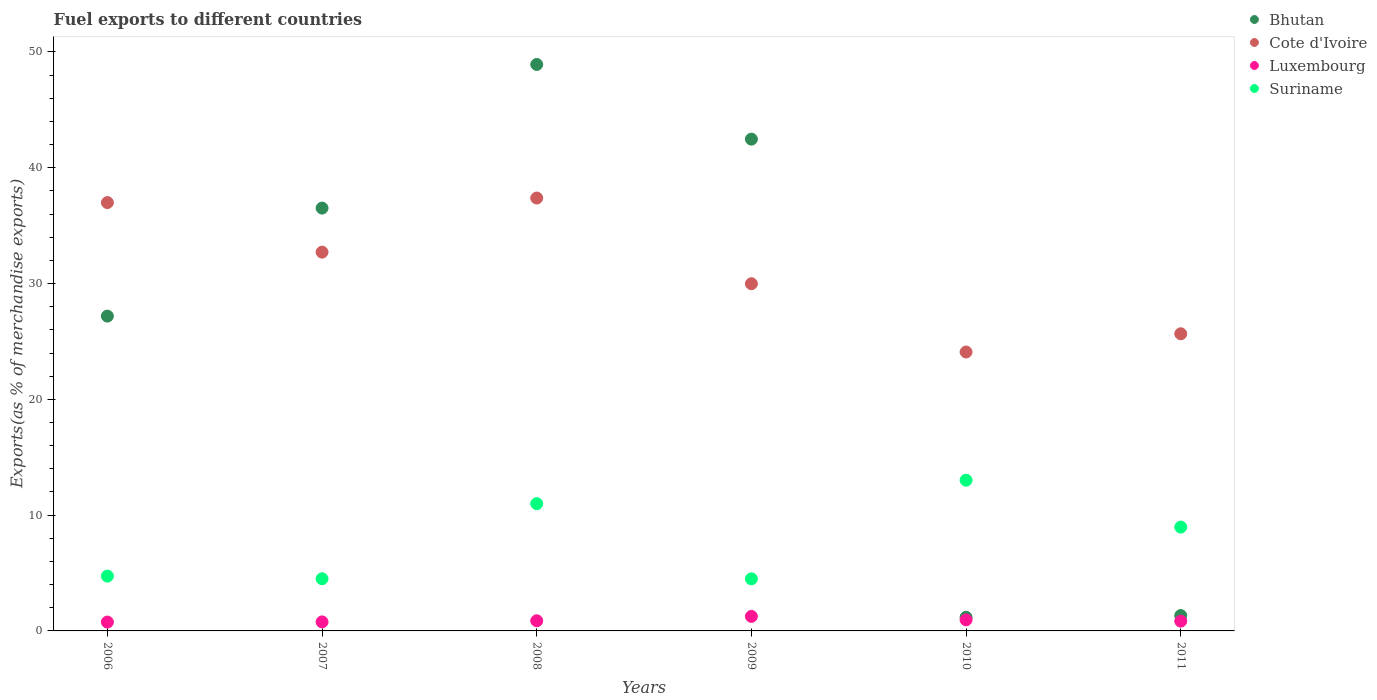What is the percentage of exports to different countries in Suriname in 2006?
Your response must be concise. 4.73. Across all years, what is the maximum percentage of exports to different countries in Luxembourg?
Your answer should be very brief. 1.26. Across all years, what is the minimum percentage of exports to different countries in Bhutan?
Provide a succinct answer. 1.18. In which year was the percentage of exports to different countries in Luxembourg maximum?
Keep it short and to the point. 2009. In which year was the percentage of exports to different countries in Luxembourg minimum?
Offer a very short reply. 2006. What is the total percentage of exports to different countries in Bhutan in the graph?
Ensure brevity in your answer.  157.59. What is the difference between the percentage of exports to different countries in Bhutan in 2007 and that in 2010?
Your answer should be compact. 35.34. What is the difference between the percentage of exports to different countries in Suriname in 2006 and the percentage of exports to different countries in Cote d'Ivoire in 2009?
Give a very brief answer. -25.25. What is the average percentage of exports to different countries in Luxembourg per year?
Provide a succinct answer. 0.91. In the year 2006, what is the difference between the percentage of exports to different countries in Suriname and percentage of exports to different countries in Bhutan?
Provide a short and direct response. -22.45. What is the ratio of the percentage of exports to different countries in Suriname in 2010 to that in 2011?
Ensure brevity in your answer.  1.45. What is the difference between the highest and the second highest percentage of exports to different countries in Luxembourg?
Ensure brevity in your answer.  0.3. What is the difference between the highest and the lowest percentage of exports to different countries in Luxembourg?
Your response must be concise. 0.49. In how many years, is the percentage of exports to different countries in Bhutan greater than the average percentage of exports to different countries in Bhutan taken over all years?
Offer a terse response. 4. Is it the case that in every year, the sum of the percentage of exports to different countries in Bhutan and percentage of exports to different countries in Cote d'Ivoire  is greater than the sum of percentage of exports to different countries in Luxembourg and percentage of exports to different countries in Suriname?
Provide a short and direct response. No. Is it the case that in every year, the sum of the percentage of exports to different countries in Luxembourg and percentage of exports to different countries in Cote d'Ivoire  is greater than the percentage of exports to different countries in Bhutan?
Give a very brief answer. No. Is the percentage of exports to different countries in Bhutan strictly less than the percentage of exports to different countries in Cote d'Ivoire over the years?
Keep it short and to the point. No. How many years are there in the graph?
Provide a succinct answer. 6. Does the graph contain grids?
Make the answer very short. No. How many legend labels are there?
Provide a short and direct response. 4. How are the legend labels stacked?
Offer a terse response. Vertical. What is the title of the graph?
Give a very brief answer. Fuel exports to different countries. Does "Australia" appear as one of the legend labels in the graph?
Make the answer very short. No. What is the label or title of the Y-axis?
Provide a succinct answer. Exports(as % of merchandise exports). What is the Exports(as % of merchandise exports) in Bhutan in 2006?
Make the answer very short. 27.19. What is the Exports(as % of merchandise exports) in Cote d'Ivoire in 2006?
Provide a succinct answer. 36.99. What is the Exports(as % of merchandise exports) in Luxembourg in 2006?
Offer a terse response. 0.76. What is the Exports(as % of merchandise exports) of Suriname in 2006?
Ensure brevity in your answer.  4.73. What is the Exports(as % of merchandise exports) in Bhutan in 2007?
Your response must be concise. 36.51. What is the Exports(as % of merchandise exports) in Cote d'Ivoire in 2007?
Your answer should be compact. 32.71. What is the Exports(as % of merchandise exports) in Luxembourg in 2007?
Your answer should be very brief. 0.78. What is the Exports(as % of merchandise exports) of Suriname in 2007?
Provide a short and direct response. 4.5. What is the Exports(as % of merchandise exports) of Bhutan in 2008?
Offer a terse response. 48.92. What is the Exports(as % of merchandise exports) of Cote d'Ivoire in 2008?
Your response must be concise. 37.38. What is the Exports(as % of merchandise exports) of Luxembourg in 2008?
Make the answer very short. 0.88. What is the Exports(as % of merchandise exports) in Suriname in 2008?
Ensure brevity in your answer.  10.99. What is the Exports(as % of merchandise exports) of Bhutan in 2009?
Your answer should be compact. 42.47. What is the Exports(as % of merchandise exports) in Cote d'Ivoire in 2009?
Your response must be concise. 29.98. What is the Exports(as % of merchandise exports) in Luxembourg in 2009?
Provide a short and direct response. 1.26. What is the Exports(as % of merchandise exports) of Suriname in 2009?
Offer a very short reply. 4.5. What is the Exports(as % of merchandise exports) in Bhutan in 2010?
Your answer should be very brief. 1.18. What is the Exports(as % of merchandise exports) in Cote d'Ivoire in 2010?
Provide a short and direct response. 24.09. What is the Exports(as % of merchandise exports) in Luxembourg in 2010?
Your answer should be very brief. 0.96. What is the Exports(as % of merchandise exports) in Suriname in 2010?
Your response must be concise. 13.02. What is the Exports(as % of merchandise exports) in Bhutan in 2011?
Provide a short and direct response. 1.33. What is the Exports(as % of merchandise exports) in Cote d'Ivoire in 2011?
Offer a very short reply. 25.66. What is the Exports(as % of merchandise exports) of Luxembourg in 2011?
Your response must be concise. 0.85. What is the Exports(as % of merchandise exports) in Suriname in 2011?
Your answer should be very brief. 8.97. Across all years, what is the maximum Exports(as % of merchandise exports) in Bhutan?
Provide a succinct answer. 48.92. Across all years, what is the maximum Exports(as % of merchandise exports) of Cote d'Ivoire?
Your response must be concise. 37.38. Across all years, what is the maximum Exports(as % of merchandise exports) of Luxembourg?
Provide a short and direct response. 1.26. Across all years, what is the maximum Exports(as % of merchandise exports) of Suriname?
Make the answer very short. 13.02. Across all years, what is the minimum Exports(as % of merchandise exports) in Bhutan?
Make the answer very short. 1.18. Across all years, what is the minimum Exports(as % of merchandise exports) of Cote d'Ivoire?
Provide a succinct answer. 24.09. Across all years, what is the minimum Exports(as % of merchandise exports) of Luxembourg?
Provide a short and direct response. 0.76. Across all years, what is the minimum Exports(as % of merchandise exports) in Suriname?
Your answer should be compact. 4.5. What is the total Exports(as % of merchandise exports) of Bhutan in the graph?
Provide a short and direct response. 157.59. What is the total Exports(as % of merchandise exports) of Cote d'Ivoire in the graph?
Ensure brevity in your answer.  186.81. What is the total Exports(as % of merchandise exports) of Luxembourg in the graph?
Make the answer very short. 5.47. What is the total Exports(as % of merchandise exports) in Suriname in the graph?
Offer a very short reply. 46.71. What is the difference between the Exports(as % of merchandise exports) of Bhutan in 2006 and that in 2007?
Your response must be concise. -9.33. What is the difference between the Exports(as % of merchandise exports) of Cote d'Ivoire in 2006 and that in 2007?
Offer a very short reply. 4.28. What is the difference between the Exports(as % of merchandise exports) of Luxembourg in 2006 and that in 2007?
Your answer should be very brief. -0.01. What is the difference between the Exports(as % of merchandise exports) of Suriname in 2006 and that in 2007?
Your answer should be very brief. 0.23. What is the difference between the Exports(as % of merchandise exports) of Bhutan in 2006 and that in 2008?
Give a very brief answer. -21.73. What is the difference between the Exports(as % of merchandise exports) in Cote d'Ivoire in 2006 and that in 2008?
Provide a short and direct response. -0.39. What is the difference between the Exports(as % of merchandise exports) in Luxembourg in 2006 and that in 2008?
Provide a succinct answer. -0.11. What is the difference between the Exports(as % of merchandise exports) in Suriname in 2006 and that in 2008?
Make the answer very short. -6.26. What is the difference between the Exports(as % of merchandise exports) of Bhutan in 2006 and that in 2009?
Give a very brief answer. -15.28. What is the difference between the Exports(as % of merchandise exports) of Cote d'Ivoire in 2006 and that in 2009?
Your response must be concise. 7.01. What is the difference between the Exports(as % of merchandise exports) of Luxembourg in 2006 and that in 2009?
Offer a terse response. -0.49. What is the difference between the Exports(as % of merchandise exports) in Suriname in 2006 and that in 2009?
Offer a very short reply. 0.24. What is the difference between the Exports(as % of merchandise exports) in Bhutan in 2006 and that in 2010?
Give a very brief answer. 26.01. What is the difference between the Exports(as % of merchandise exports) of Cote d'Ivoire in 2006 and that in 2010?
Ensure brevity in your answer.  12.9. What is the difference between the Exports(as % of merchandise exports) in Luxembourg in 2006 and that in 2010?
Your answer should be very brief. -0.19. What is the difference between the Exports(as % of merchandise exports) of Suriname in 2006 and that in 2010?
Provide a succinct answer. -8.28. What is the difference between the Exports(as % of merchandise exports) of Bhutan in 2006 and that in 2011?
Keep it short and to the point. 25.86. What is the difference between the Exports(as % of merchandise exports) of Cote d'Ivoire in 2006 and that in 2011?
Provide a succinct answer. 11.33. What is the difference between the Exports(as % of merchandise exports) in Luxembourg in 2006 and that in 2011?
Make the answer very short. -0.08. What is the difference between the Exports(as % of merchandise exports) in Suriname in 2006 and that in 2011?
Your response must be concise. -4.23. What is the difference between the Exports(as % of merchandise exports) of Bhutan in 2007 and that in 2008?
Your answer should be very brief. -12.4. What is the difference between the Exports(as % of merchandise exports) in Cote d'Ivoire in 2007 and that in 2008?
Your response must be concise. -4.67. What is the difference between the Exports(as % of merchandise exports) of Luxembourg in 2007 and that in 2008?
Your answer should be compact. -0.1. What is the difference between the Exports(as % of merchandise exports) of Suriname in 2007 and that in 2008?
Offer a terse response. -6.49. What is the difference between the Exports(as % of merchandise exports) in Bhutan in 2007 and that in 2009?
Offer a terse response. -5.95. What is the difference between the Exports(as % of merchandise exports) in Cote d'Ivoire in 2007 and that in 2009?
Keep it short and to the point. 2.73. What is the difference between the Exports(as % of merchandise exports) of Luxembourg in 2007 and that in 2009?
Provide a succinct answer. -0.48. What is the difference between the Exports(as % of merchandise exports) of Suriname in 2007 and that in 2009?
Your answer should be compact. 0.01. What is the difference between the Exports(as % of merchandise exports) of Bhutan in 2007 and that in 2010?
Keep it short and to the point. 35.34. What is the difference between the Exports(as % of merchandise exports) in Cote d'Ivoire in 2007 and that in 2010?
Keep it short and to the point. 8.62. What is the difference between the Exports(as % of merchandise exports) of Luxembourg in 2007 and that in 2010?
Your answer should be compact. -0.18. What is the difference between the Exports(as % of merchandise exports) in Suriname in 2007 and that in 2010?
Your answer should be very brief. -8.51. What is the difference between the Exports(as % of merchandise exports) in Bhutan in 2007 and that in 2011?
Your response must be concise. 35.19. What is the difference between the Exports(as % of merchandise exports) of Cote d'Ivoire in 2007 and that in 2011?
Give a very brief answer. 7.05. What is the difference between the Exports(as % of merchandise exports) of Luxembourg in 2007 and that in 2011?
Offer a very short reply. -0.07. What is the difference between the Exports(as % of merchandise exports) of Suriname in 2007 and that in 2011?
Make the answer very short. -4.46. What is the difference between the Exports(as % of merchandise exports) in Bhutan in 2008 and that in 2009?
Your answer should be compact. 6.45. What is the difference between the Exports(as % of merchandise exports) in Cote d'Ivoire in 2008 and that in 2009?
Ensure brevity in your answer.  7.4. What is the difference between the Exports(as % of merchandise exports) of Luxembourg in 2008 and that in 2009?
Your answer should be very brief. -0.38. What is the difference between the Exports(as % of merchandise exports) in Suriname in 2008 and that in 2009?
Give a very brief answer. 6.49. What is the difference between the Exports(as % of merchandise exports) of Bhutan in 2008 and that in 2010?
Offer a terse response. 47.74. What is the difference between the Exports(as % of merchandise exports) in Cote d'Ivoire in 2008 and that in 2010?
Provide a succinct answer. 13.3. What is the difference between the Exports(as % of merchandise exports) of Luxembourg in 2008 and that in 2010?
Make the answer very short. -0.08. What is the difference between the Exports(as % of merchandise exports) in Suriname in 2008 and that in 2010?
Your answer should be very brief. -2.02. What is the difference between the Exports(as % of merchandise exports) in Bhutan in 2008 and that in 2011?
Offer a very short reply. 47.59. What is the difference between the Exports(as % of merchandise exports) in Cote d'Ivoire in 2008 and that in 2011?
Offer a very short reply. 11.72. What is the difference between the Exports(as % of merchandise exports) of Luxembourg in 2008 and that in 2011?
Offer a very short reply. 0.03. What is the difference between the Exports(as % of merchandise exports) of Suriname in 2008 and that in 2011?
Offer a very short reply. 2.02. What is the difference between the Exports(as % of merchandise exports) of Bhutan in 2009 and that in 2010?
Your answer should be very brief. 41.29. What is the difference between the Exports(as % of merchandise exports) in Cote d'Ivoire in 2009 and that in 2010?
Keep it short and to the point. 5.9. What is the difference between the Exports(as % of merchandise exports) of Luxembourg in 2009 and that in 2010?
Keep it short and to the point. 0.3. What is the difference between the Exports(as % of merchandise exports) of Suriname in 2009 and that in 2010?
Ensure brevity in your answer.  -8.52. What is the difference between the Exports(as % of merchandise exports) in Bhutan in 2009 and that in 2011?
Provide a short and direct response. 41.14. What is the difference between the Exports(as % of merchandise exports) of Cote d'Ivoire in 2009 and that in 2011?
Your answer should be compact. 4.32. What is the difference between the Exports(as % of merchandise exports) of Luxembourg in 2009 and that in 2011?
Make the answer very short. 0.41. What is the difference between the Exports(as % of merchandise exports) of Suriname in 2009 and that in 2011?
Make the answer very short. -4.47. What is the difference between the Exports(as % of merchandise exports) of Bhutan in 2010 and that in 2011?
Give a very brief answer. -0.15. What is the difference between the Exports(as % of merchandise exports) in Cote d'Ivoire in 2010 and that in 2011?
Your response must be concise. -1.57. What is the difference between the Exports(as % of merchandise exports) of Luxembourg in 2010 and that in 2011?
Offer a very short reply. 0.11. What is the difference between the Exports(as % of merchandise exports) in Suriname in 2010 and that in 2011?
Keep it short and to the point. 4.05. What is the difference between the Exports(as % of merchandise exports) of Bhutan in 2006 and the Exports(as % of merchandise exports) of Cote d'Ivoire in 2007?
Your answer should be compact. -5.52. What is the difference between the Exports(as % of merchandise exports) in Bhutan in 2006 and the Exports(as % of merchandise exports) in Luxembourg in 2007?
Your response must be concise. 26.41. What is the difference between the Exports(as % of merchandise exports) of Bhutan in 2006 and the Exports(as % of merchandise exports) of Suriname in 2007?
Your answer should be compact. 22.68. What is the difference between the Exports(as % of merchandise exports) in Cote d'Ivoire in 2006 and the Exports(as % of merchandise exports) in Luxembourg in 2007?
Give a very brief answer. 36.21. What is the difference between the Exports(as % of merchandise exports) in Cote d'Ivoire in 2006 and the Exports(as % of merchandise exports) in Suriname in 2007?
Keep it short and to the point. 32.49. What is the difference between the Exports(as % of merchandise exports) in Luxembourg in 2006 and the Exports(as % of merchandise exports) in Suriname in 2007?
Give a very brief answer. -3.74. What is the difference between the Exports(as % of merchandise exports) in Bhutan in 2006 and the Exports(as % of merchandise exports) in Cote d'Ivoire in 2008?
Make the answer very short. -10.2. What is the difference between the Exports(as % of merchandise exports) of Bhutan in 2006 and the Exports(as % of merchandise exports) of Luxembourg in 2008?
Offer a terse response. 26.31. What is the difference between the Exports(as % of merchandise exports) in Bhutan in 2006 and the Exports(as % of merchandise exports) in Suriname in 2008?
Give a very brief answer. 16.2. What is the difference between the Exports(as % of merchandise exports) of Cote d'Ivoire in 2006 and the Exports(as % of merchandise exports) of Luxembourg in 2008?
Provide a short and direct response. 36.11. What is the difference between the Exports(as % of merchandise exports) in Cote d'Ivoire in 2006 and the Exports(as % of merchandise exports) in Suriname in 2008?
Provide a short and direct response. 26. What is the difference between the Exports(as % of merchandise exports) in Luxembourg in 2006 and the Exports(as % of merchandise exports) in Suriname in 2008?
Ensure brevity in your answer.  -10.23. What is the difference between the Exports(as % of merchandise exports) in Bhutan in 2006 and the Exports(as % of merchandise exports) in Cote d'Ivoire in 2009?
Your answer should be compact. -2.8. What is the difference between the Exports(as % of merchandise exports) in Bhutan in 2006 and the Exports(as % of merchandise exports) in Luxembourg in 2009?
Your answer should be very brief. 25.93. What is the difference between the Exports(as % of merchandise exports) of Bhutan in 2006 and the Exports(as % of merchandise exports) of Suriname in 2009?
Offer a very short reply. 22.69. What is the difference between the Exports(as % of merchandise exports) in Cote d'Ivoire in 2006 and the Exports(as % of merchandise exports) in Luxembourg in 2009?
Ensure brevity in your answer.  35.73. What is the difference between the Exports(as % of merchandise exports) in Cote d'Ivoire in 2006 and the Exports(as % of merchandise exports) in Suriname in 2009?
Your response must be concise. 32.49. What is the difference between the Exports(as % of merchandise exports) of Luxembourg in 2006 and the Exports(as % of merchandise exports) of Suriname in 2009?
Offer a very short reply. -3.73. What is the difference between the Exports(as % of merchandise exports) of Bhutan in 2006 and the Exports(as % of merchandise exports) of Cote d'Ivoire in 2010?
Keep it short and to the point. 3.1. What is the difference between the Exports(as % of merchandise exports) of Bhutan in 2006 and the Exports(as % of merchandise exports) of Luxembourg in 2010?
Your response must be concise. 26.23. What is the difference between the Exports(as % of merchandise exports) in Bhutan in 2006 and the Exports(as % of merchandise exports) in Suriname in 2010?
Offer a very short reply. 14.17. What is the difference between the Exports(as % of merchandise exports) in Cote d'Ivoire in 2006 and the Exports(as % of merchandise exports) in Luxembourg in 2010?
Ensure brevity in your answer.  36.03. What is the difference between the Exports(as % of merchandise exports) in Cote d'Ivoire in 2006 and the Exports(as % of merchandise exports) in Suriname in 2010?
Provide a short and direct response. 23.97. What is the difference between the Exports(as % of merchandise exports) of Luxembourg in 2006 and the Exports(as % of merchandise exports) of Suriname in 2010?
Your answer should be compact. -12.25. What is the difference between the Exports(as % of merchandise exports) of Bhutan in 2006 and the Exports(as % of merchandise exports) of Cote d'Ivoire in 2011?
Offer a very short reply. 1.53. What is the difference between the Exports(as % of merchandise exports) of Bhutan in 2006 and the Exports(as % of merchandise exports) of Luxembourg in 2011?
Your answer should be very brief. 26.34. What is the difference between the Exports(as % of merchandise exports) of Bhutan in 2006 and the Exports(as % of merchandise exports) of Suriname in 2011?
Your answer should be very brief. 18.22. What is the difference between the Exports(as % of merchandise exports) of Cote d'Ivoire in 2006 and the Exports(as % of merchandise exports) of Luxembourg in 2011?
Your response must be concise. 36.14. What is the difference between the Exports(as % of merchandise exports) in Cote d'Ivoire in 2006 and the Exports(as % of merchandise exports) in Suriname in 2011?
Your response must be concise. 28.02. What is the difference between the Exports(as % of merchandise exports) of Luxembourg in 2006 and the Exports(as % of merchandise exports) of Suriname in 2011?
Your response must be concise. -8.2. What is the difference between the Exports(as % of merchandise exports) in Bhutan in 2007 and the Exports(as % of merchandise exports) in Cote d'Ivoire in 2008?
Ensure brevity in your answer.  -0.87. What is the difference between the Exports(as % of merchandise exports) of Bhutan in 2007 and the Exports(as % of merchandise exports) of Luxembourg in 2008?
Provide a succinct answer. 35.64. What is the difference between the Exports(as % of merchandise exports) in Bhutan in 2007 and the Exports(as % of merchandise exports) in Suriname in 2008?
Keep it short and to the point. 25.52. What is the difference between the Exports(as % of merchandise exports) in Cote d'Ivoire in 2007 and the Exports(as % of merchandise exports) in Luxembourg in 2008?
Your answer should be compact. 31.83. What is the difference between the Exports(as % of merchandise exports) in Cote d'Ivoire in 2007 and the Exports(as % of merchandise exports) in Suriname in 2008?
Your response must be concise. 21.72. What is the difference between the Exports(as % of merchandise exports) in Luxembourg in 2007 and the Exports(as % of merchandise exports) in Suriname in 2008?
Your answer should be compact. -10.21. What is the difference between the Exports(as % of merchandise exports) of Bhutan in 2007 and the Exports(as % of merchandise exports) of Cote d'Ivoire in 2009?
Provide a short and direct response. 6.53. What is the difference between the Exports(as % of merchandise exports) in Bhutan in 2007 and the Exports(as % of merchandise exports) in Luxembourg in 2009?
Give a very brief answer. 35.26. What is the difference between the Exports(as % of merchandise exports) in Bhutan in 2007 and the Exports(as % of merchandise exports) in Suriname in 2009?
Offer a very short reply. 32.02. What is the difference between the Exports(as % of merchandise exports) of Cote d'Ivoire in 2007 and the Exports(as % of merchandise exports) of Luxembourg in 2009?
Offer a very short reply. 31.45. What is the difference between the Exports(as % of merchandise exports) of Cote d'Ivoire in 2007 and the Exports(as % of merchandise exports) of Suriname in 2009?
Provide a short and direct response. 28.21. What is the difference between the Exports(as % of merchandise exports) of Luxembourg in 2007 and the Exports(as % of merchandise exports) of Suriname in 2009?
Provide a succinct answer. -3.72. What is the difference between the Exports(as % of merchandise exports) of Bhutan in 2007 and the Exports(as % of merchandise exports) of Cote d'Ivoire in 2010?
Offer a terse response. 12.43. What is the difference between the Exports(as % of merchandise exports) of Bhutan in 2007 and the Exports(as % of merchandise exports) of Luxembourg in 2010?
Give a very brief answer. 35.56. What is the difference between the Exports(as % of merchandise exports) of Bhutan in 2007 and the Exports(as % of merchandise exports) of Suriname in 2010?
Make the answer very short. 23.5. What is the difference between the Exports(as % of merchandise exports) of Cote d'Ivoire in 2007 and the Exports(as % of merchandise exports) of Luxembourg in 2010?
Give a very brief answer. 31.75. What is the difference between the Exports(as % of merchandise exports) of Cote d'Ivoire in 2007 and the Exports(as % of merchandise exports) of Suriname in 2010?
Your response must be concise. 19.69. What is the difference between the Exports(as % of merchandise exports) of Luxembourg in 2007 and the Exports(as % of merchandise exports) of Suriname in 2010?
Offer a very short reply. -12.24. What is the difference between the Exports(as % of merchandise exports) in Bhutan in 2007 and the Exports(as % of merchandise exports) in Cote d'Ivoire in 2011?
Keep it short and to the point. 10.85. What is the difference between the Exports(as % of merchandise exports) of Bhutan in 2007 and the Exports(as % of merchandise exports) of Luxembourg in 2011?
Give a very brief answer. 35.67. What is the difference between the Exports(as % of merchandise exports) in Bhutan in 2007 and the Exports(as % of merchandise exports) in Suriname in 2011?
Give a very brief answer. 27.55. What is the difference between the Exports(as % of merchandise exports) in Cote d'Ivoire in 2007 and the Exports(as % of merchandise exports) in Luxembourg in 2011?
Ensure brevity in your answer.  31.87. What is the difference between the Exports(as % of merchandise exports) of Cote d'Ivoire in 2007 and the Exports(as % of merchandise exports) of Suriname in 2011?
Offer a very short reply. 23.74. What is the difference between the Exports(as % of merchandise exports) of Luxembourg in 2007 and the Exports(as % of merchandise exports) of Suriname in 2011?
Offer a terse response. -8.19. What is the difference between the Exports(as % of merchandise exports) of Bhutan in 2008 and the Exports(as % of merchandise exports) of Cote d'Ivoire in 2009?
Provide a succinct answer. 18.93. What is the difference between the Exports(as % of merchandise exports) in Bhutan in 2008 and the Exports(as % of merchandise exports) in Luxembourg in 2009?
Your answer should be very brief. 47.66. What is the difference between the Exports(as % of merchandise exports) of Bhutan in 2008 and the Exports(as % of merchandise exports) of Suriname in 2009?
Your response must be concise. 44.42. What is the difference between the Exports(as % of merchandise exports) of Cote d'Ivoire in 2008 and the Exports(as % of merchandise exports) of Luxembourg in 2009?
Keep it short and to the point. 36.13. What is the difference between the Exports(as % of merchandise exports) in Cote d'Ivoire in 2008 and the Exports(as % of merchandise exports) in Suriname in 2009?
Your response must be concise. 32.88. What is the difference between the Exports(as % of merchandise exports) of Luxembourg in 2008 and the Exports(as % of merchandise exports) of Suriname in 2009?
Your answer should be very brief. -3.62. What is the difference between the Exports(as % of merchandise exports) in Bhutan in 2008 and the Exports(as % of merchandise exports) in Cote d'Ivoire in 2010?
Offer a terse response. 24.83. What is the difference between the Exports(as % of merchandise exports) in Bhutan in 2008 and the Exports(as % of merchandise exports) in Luxembourg in 2010?
Ensure brevity in your answer.  47.96. What is the difference between the Exports(as % of merchandise exports) in Bhutan in 2008 and the Exports(as % of merchandise exports) in Suriname in 2010?
Make the answer very short. 35.9. What is the difference between the Exports(as % of merchandise exports) in Cote d'Ivoire in 2008 and the Exports(as % of merchandise exports) in Luxembourg in 2010?
Your response must be concise. 36.43. What is the difference between the Exports(as % of merchandise exports) of Cote d'Ivoire in 2008 and the Exports(as % of merchandise exports) of Suriname in 2010?
Give a very brief answer. 24.37. What is the difference between the Exports(as % of merchandise exports) of Luxembourg in 2008 and the Exports(as % of merchandise exports) of Suriname in 2010?
Your response must be concise. -12.14. What is the difference between the Exports(as % of merchandise exports) in Bhutan in 2008 and the Exports(as % of merchandise exports) in Cote d'Ivoire in 2011?
Your answer should be compact. 23.26. What is the difference between the Exports(as % of merchandise exports) in Bhutan in 2008 and the Exports(as % of merchandise exports) in Luxembourg in 2011?
Provide a succinct answer. 48.07. What is the difference between the Exports(as % of merchandise exports) of Bhutan in 2008 and the Exports(as % of merchandise exports) of Suriname in 2011?
Provide a succinct answer. 39.95. What is the difference between the Exports(as % of merchandise exports) of Cote d'Ivoire in 2008 and the Exports(as % of merchandise exports) of Luxembourg in 2011?
Your response must be concise. 36.54. What is the difference between the Exports(as % of merchandise exports) in Cote d'Ivoire in 2008 and the Exports(as % of merchandise exports) in Suriname in 2011?
Provide a succinct answer. 28.42. What is the difference between the Exports(as % of merchandise exports) in Luxembourg in 2008 and the Exports(as % of merchandise exports) in Suriname in 2011?
Your answer should be compact. -8.09. What is the difference between the Exports(as % of merchandise exports) of Bhutan in 2009 and the Exports(as % of merchandise exports) of Cote d'Ivoire in 2010?
Your response must be concise. 18.38. What is the difference between the Exports(as % of merchandise exports) of Bhutan in 2009 and the Exports(as % of merchandise exports) of Luxembourg in 2010?
Your answer should be compact. 41.51. What is the difference between the Exports(as % of merchandise exports) of Bhutan in 2009 and the Exports(as % of merchandise exports) of Suriname in 2010?
Your response must be concise. 29.45. What is the difference between the Exports(as % of merchandise exports) in Cote d'Ivoire in 2009 and the Exports(as % of merchandise exports) in Luxembourg in 2010?
Your answer should be compact. 29.03. What is the difference between the Exports(as % of merchandise exports) in Cote d'Ivoire in 2009 and the Exports(as % of merchandise exports) in Suriname in 2010?
Your answer should be very brief. 16.97. What is the difference between the Exports(as % of merchandise exports) of Luxembourg in 2009 and the Exports(as % of merchandise exports) of Suriname in 2010?
Your response must be concise. -11.76. What is the difference between the Exports(as % of merchandise exports) of Bhutan in 2009 and the Exports(as % of merchandise exports) of Cote d'Ivoire in 2011?
Provide a short and direct response. 16.81. What is the difference between the Exports(as % of merchandise exports) in Bhutan in 2009 and the Exports(as % of merchandise exports) in Luxembourg in 2011?
Your response must be concise. 41.62. What is the difference between the Exports(as % of merchandise exports) in Bhutan in 2009 and the Exports(as % of merchandise exports) in Suriname in 2011?
Provide a short and direct response. 33.5. What is the difference between the Exports(as % of merchandise exports) in Cote d'Ivoire in 2009 and the Exports(as % of merchandise exports) in Luxembourg in 2011?
Give a very brief answer. 29.14. What is the difference between the Exports(as % of merchandise exports) of Cote d'Ivoire in 2009 and the Exports(as % of merchandise exports) of Suriname in 2011?
Provide a short and direct response. 21.02. What is the difference between the Exports(as % of merchandise exports) in Luxembourg in 2009 and the Exports(as % of merchandise exports) in Suriname in 2011?
Offer a very short reply. -7.71. What is the difference between the Exports(as % of merchandise exports) in Bhutan in 2010 and the Exports(as % of merchandise exports) in Cote d'Ivoire in 2011?
Provide a short and direct response. -24.48. What is the difference between the Exports(as % of merchandise exports) of Bhutan in 2010 and the Exports(as % of merchandise exports) of Luxembourg in 2011?
Offer a very short reply. 0.33. What is the difference between the Exports(as % of merchandise exports) of Bhutan in 2010 and the Exports(as % of merchandise exports) of Suriname in 2011?
Keep it short and to the point. -7.79. What is the difference between the Exports(as % of merchandise exports) of Cote d'Ivoire in 2010 and the Exports(as % of merchandise exports) of Luxembourg in 2011?
Keep it short and to the point. 23.24. What is the difference between the Exports(as % of merchandise exports) of Cote d'Ivoire in 2010 and the Exports(as % of merchandise exports) of Suriname in 2011?
Offer a terse response. 15.12. What is the difference between the Exports(as % of merchandise exports) in Luxembourg in 2010 and the Exports(as % of merchandise exports) in Suriname in 2011?
Ensure brevity in your answer.  -8.01. What is the average Exports(as % of merchandise exports) of Bhutan per year?
Provide a succinct answer. 26.27. What is the average Exports(as % of merchandise exports) of Cote d'Ivoire per year?
Provide a succinct answer. 31.14. What is the average Exports(as % of merchandise exports) of Luxembourg per year?
Make the answer very short. 0.91. What is the average Exports(as % of merchandise exports) of Suriname per year?
Offer a very short reply. 7.78. In the year 2006, what is the difference between the Exports(as % of merchandise exports) in Bhutan and Exports(as % of merchandise exports) in Cote d'Ivoire?
Make the answer very short. -9.8. In the year 2006, what is the difference between the Exports(as % of merchandise exports) in Bhutan and Exports(as % of merchandise exports) in Luxembourg?
Give a very brief answer. 26.42. In the year 2006, what is the difference between the Exports(as % of merchandise exports) of Bhutan and Exports(as % of merchandise exports) of Suriname?
Your response must be concise. 22.45. In the year 2006, what is the difference between the Exports(as % of merchandise exports) in Cote d'Ivoire and Exports(as % of merchandise exports) in Luxembourg?
Your answer should be compact. 36.23. In the year 2006, what is the difference between the Exports(as % of merchandise exports) of Cote d'Ivoire and Exports(as % of merchandise exports) of Suriname?
Your answer should be very brief. 32.25. In the year 2006, what is the difference between the Exports(as % of merchandise exports) in Luxembourg and Exports(as % of merchandise exports) in Suriname?
Keep it short and to the point. -3.97. In the year 2007, what is the difference between the Exports(as % of merchandise exports) of Bhutan and Exports(as % of merchandise exports) of Cote d'Ivoire?
Your answer should be compact. 3.8. In the year 2007, what is the difference between the Exports(as % of merchandise exports) in Bhutan and Exports(as % of merchandise exports) in Luxembourg?
Ensure brevity in your answer.  35.74. In the year 2007, what is the difference between the Exports(as % of merchandise exports) of Bhutan and Exports(as % of merchandise exports) of Suriname?
Give a very brief answer. 32.01. In the year 2007, what is the difference between the Exports(as % of merchandise exports) of Cote d'Ivoire and Exports(as % of merchandise exports) of Luxembourg?
Ensure brevity in your answer.  31.93. In the year 2007, what is the difference between the Exports(as % of merchandise exports) of Cote d'Ivoire and Exports(as % of merchandise exports) of Suriname?
Your answer should be compact. 28.21. In the year 2007, what is the difference between the Exports(as % of merchandise exports) in Luxembourg and Exports(as % of merchandise exports) in Suriname?
Your answer should be compact. -3.72. In the year 2008, what is the difference between the Exports(as % of merchandise exports) in Bhutan and Exports(as % of merchandise exports) in Cote d'Ivoire?
Offer a very short reply. 11.54. In the year 2008, what is the difference between the Exports(as % of merchandise exports) of Bhutan and Exports(as % of merchandise exports) of Luxembourg?
Ensure brevity in your answer.  48.04. In the year 2008, what is the difference between the Exports(as % of merchandise exports) in Bhutan and Exports(as % of merchandise exports) in Suriname?
Offer a terse response. 37.93. In the year 2008, what is the difference between the Exports(as % of merchandise exports) in Cote d'Ivoire and Exports(as % of merchandise exports) in Luxembourg?
Your answer should be very brief. 36.51. In the year 2008, what is the difference between the Exports(as % of merchandise exports) of Cote d'Ivoire and Exports(as % of merchandise exports) of Suriname?
Your answer should be compact. 26.39. In the year 2008, what is the difference between the Exports(as % of merchandise exports) in Luxembourg and Exports(as % of merchandise exports) in Suriname?
Offer a very short reply. -10.11. In the year 2009, what is the difference between the Exports(as % of merchandise exports) in Bhutan and Exports(as % of merchandise exports) in Cote d'Ivoire?
Offer a terse response. 12.49. In the year 2009, what is the difference between the Exports(as % of merchandise exports) of Bhutan and Exports(as % of merchandise exports) of Luxembourg?
Your response must be concise. 41.21. In the year 2009, what is the difference between the Exports(as % of merchandise exports) of Bhutan and Exports(as % of merchandise exports) of Suriname?
Your answer should be very brief. 37.97. In the year 2009, what is the difference between the Exports(as % of merchandise exports) of Cote d'Ivoire and Exports(as % of merchandise exports) of Luxembourg?
Provide a short and direct response. 28.73. In the year 2009, what is the difference between the Exports(as % of merchandise exports) of Cote d'Ivoire and Exports(as % of merchandise exports) of Suriname?
Provide a succinct answer. 25.49. In the year 2009, what is the difference between the Exports(as % of merchandise exports) of Luxembourg and Exports(as % of merchandise exports) of Suriname?
Provide a succinct answer. -3.24. In the year 2010, what is the difference between the Exports(as % of merchandise exports) in Bhutan and Exports(as % of merchandise exports) in Cote d'Ivoire?
Provide a succinct answer. -22.91. In the year 2010, what is the difference between the Exports(as % of merchandise exports) in Bhutan and Exports(as % of merchandise exports) in Luxembourg?
Ensure brevity in your answer.  0.22. In the year 2010, what is the difference between the Exports(as % of merchandise exports) of Bhutan and Exports(as % of merchandise exports) of Suriname?
Ensure brevity in your answer.  -11.84. In the year 2010, what is the difference between the Exports(as % of merchandise exports) in Cote d'Ivoire and Exports(as % of merchandise exports) in Luxembourg?
Offer a terse response. 23.13. In the year 2010, what is the difference between the Exports(as % of merchandise exports) in Cote d'Ivoire and Exports(as % of merchandise exports) in Suriname?
Make the answer very short. 11.07. In the year 2010, what is the difference between the Exports(as % of merchandise exports) of Luxembourg and Exports(as % of merchandise exports) of Suriname?
Keep it short and to the point. -12.06. In the year 2011, what is the difference between the Exports(as % of merchandise exports) of Bhutan and Exports(as % of merchandise exports) of Cote d'Ivoire?
Give a very brief answer. -24.33. In the year 2011, what is the difference between the Exports(as % of merchandise exports) in Bhutan and Exports(as % of merchandise exports) in Luxembourg?
Offer a terse response. 0.48. In the year 2011, what is the difference between the Exports(as % of merchandise exports) in Bhutan and Exports(as % of merchandise exports) in Suriname?
Offer a terse response. -7.64. In the year 2011, what is the difference between the Exports(as % of merchandise exports) of Cote d'Ivoire and Exports(as % of merchandise exports) of Luxembourg?
Your answer should be very brief. 24.82. In the year 2011, what is the difference between the Exports(as % of merchandise exports) of Cote d'Ivoire and Exports(as % of merchandise exports) of Suriname?
Your response must be concise. 16.69. In the year 2011, what is the difference between the Exports(as % of merchandise exports) of Luxembourg and Exports(as % of merchandise exports) of Suriname?
Provide a succinct answer. -8.12. What is the ratio of the Exports(as % of merchandise exports) in Bhutan in 2006 to that in 2007?
Offer a terse response. 0.74. What is the ratio of the Exports(as % of merchandise exports) of Cote d'Ivoire in 2006 to that in 2007?
Offer a terse response. 1.13. What is the ratio of the Exports(as % of merchandise exports) in Luxembourg in 2006 to that in 2007?
Give a very brief answer. 0.98. What is the ratio of the Exports(as % of merchandise exports) of Suriname in 2006 to that in 2007?
Offer a terse response. 1.05. What is the ratio of the Exports(as % of merchandise exports) in Bhutan in 2006 to that in 2008?
Provide a short and direct response. 0.56. What is the ratio of the Exports(as % of merchandise exports) in Luxembourg in 2006 to that in 2008?
Give a very brief answer. 0.87. What is the ratio of the Exports(as % of merchandise exports) in Suriname in 2006 to that in 2008?
Keep it short and to the point. 0.43. What is the ratio of the Exports(as % of merchandise exports) of Bhutan in 2006 to that in 2009?
Offer a very short reply. 0.64. What is the ratio of the Exports(as % of merchandise exports) of Cote d'Ivoire in 2006 to that in 2009?
Provide a succinct answer. 1.23. What is the ratio of the Exports(as % of merchandise exports) in Luxembourg in 2006 to that in 2009?
Your answer should be very brief. 0.61. What is the ratio of the Exports(as % of merchandise exports) in Suriname in 2006 to that in 2009?
Provide a succinct answer. 1.05. What is the ratio of the Exports(as % of merchandise exports) in Bhutan in 2006 to that in 2010?
Your answer should be very brief. 23.05. What is the ratio of the Exports(as % of merchandise exports) of Cote d'Ivoire in 2006 to that in 2010?
Offer a very short reply. 1.54. What is the ratio of the Exports(as % of merchandise exports) in Luxembourg in 2006 to that in 2010?
Provide a succinct answer. 0.8. What is the ratio of the Exports(as % of merchandise exports) in Suriname in 2006 to that in 2010?
Your response must be concise. 0.36. What is the ratio of the Exports(as % of merchandise exports) of Bhutan in 2006 to that in 2011?
Your response must be concise. 20.5. What is the ratio of the Exports(as % of merchandise exports) in Cote d'Ivoire in 2006 to that in 2011?
Your response must be concise. 1.44. What is the ratio of the Exports(as % of merchandise exports) of Luxembourg in 2006 to that in 2011?
Ensure brevity in your answer.  0.9. What is the ratio of the Exports(as % of merchandise exports) of Suriname in 2006 to that in 2011?
Provide a succinct answer. 0.53. What is the ratio of the Exports(as % of merchandise exports) in Bhutan in 2007 to that in 2008?
Your response must be concise. 0.75. What is the ratio of the Exports(as % of merchandise exports) in Cote d'Ivoire in 2007 to that in 2008?
Keep it short and to the point. 0.88. What is the ratio of the Exports(as % of merchandise exports) of Luxembourg in 2007 to that in 2008?
Offer a very short reply. 0.89. What is the ratio of the Exports(as % of merchandise exports) in Suriname in 2007 to that in 2008?
Offer a terse response. 0.41. What is the ratio of the Exports(as % of merchandise exports) of Bhutan in 2007 to that in 2009?
Provide a succinct answer. 0.86. What is the ratio of the Exports(as % of merchandise exports) of Cote d'Ivoire in 2007 to that in 2009?
Give a very brief answer. 1.09. What is the ratio of the Exports(as % of merchandise exports) of Luxembourg in 2007 to that in 2009?
Provide a succinct answer. 0.62. What is the ratio of the Exports(as % of merchandise exports) in Bhutan in 2007 to that in 2010?
Ensure brevity in your answer.  30.96. What is the ratio of the Exports(as % of merchandise exports) in Cote d'Ivoire in 2007 to that in 2010?
Provide a succinct answer. 1.36. What is the ratio of the Exports(as % of merchandise exports) in Luxembourg in 2007 to that in 2010?
Provide a short and direct response. 0.81. What is the ratio of the Exports(as % of merchandise exports) of Suriname in 2007 to that in 2010?
Your answer should be compact. 0.35. What is the ratio of the Exports(as % of merchandise exports) of Bhutan in 2007 to that in 2011?
Your answer should be very brief. 27.54. What is the ratio of the Exports(as % of merchandise exports) in Cote d'Ivoire in 2007 to that in 2011?
Give a very brief answer. 1.27. What is the ratio of the Exports(as % of merchandise exports) in Luxembourg in 2007 to that in 2011?
Your response must be concise. 0.92. What is the ratio of the Exports(as % of merchandise exports) of Suriname in 2007 to that in 2011?
Your answer should be very brief. 0.5. What is the ratio of the Exports(as % of merchandise exports) of Bhutan in 2008 to that in 2009?
Ensure brevity in your answer.  1.15. What is the ratio of the Exports(as % of merchandise exports) in Cote d'Ivoire in 2008 to that in 2009?
Ensure brevity in your answer.  1.25. What is the ratio of the Exports(as % of merchandise exports) in Luxembourg in 2008 to that in 2009?
Ensure brevity in your answer.  0.7. What is the ratio of the Exports(as % of merchandise exports) of Suriname in 2008 to that in 2009?
Ensure brevity in your answer.  2.44. What is the ratio of the Exports(as % of merchandise exports) in Bhutan in 2008 to that in 2010?
Your response must be concise. 41.48. What is the ratio of the Exports(as % of merchandise exports) in Cote d'Ivoire in 2008 to that in 2010?
Your answer should be compact. 1.55. What is the ratio of the Exports(as % of merchandise exports) of Luxembourg in 2008 to that in 2010?
Provide a succinct answer. 0.92. What is the ratio of the Exports(as % of merchandise exports) of Suriname in 2008 to that in 2010?
Keep it short and to the point. 0.84. What is the ratio of the Exports(as % of merchandise exports) of Bhutan in 2008 to that in 2011?
Offer a very short reply. 36.89. What is the ratio of the Exports(as % of merchandise exports) of Cote d'Ivoire in 2008 to that in 2011?
Keep it short and to the point. 1.46. What is the ratio of the Exports(as % of merchandise exports) of Luxembourg in 2008 to that in 2011?
Give a very brief answer. 1.04. What is the ratio of the Exports(as % of merchandise exports) in Suriname in 2008 to that in 2011?
Your response must be concise. 1.23. What is the ratio of the Exports(as % of merchandise exports) in Bhutan in 2009 to that in 2010?
Your answer should be very brief. 36.01. What is the ratio of the Exports(as % of merchandise exports) of Cote d'Ivoire in 2009 to that in 2010?
Your answer should be very brief. 1.24. What is the ratio of the Exports(as % of merchandise exports) in Luxembourg in 2009 to that in 2010?
Offer a terse response. 1.31. What is the ratio of the Exports(as % of merchandise exports) of Suriname in 2009 to that in 2010?
Provide a succinct answer. 0.35. What is the ratio of the Exports(as % of merchandise exports) of Bhutan in 2009 to that in 2011?
Your response must be concise. 32.03. What is the ratio of the Exports(as % of merchandise exports) of Cote d'Ivoire in 2009 to that in 2011?
Provide a short and direct response. 1.17. What is the ratio of the Exports(as % of merchandise exports) in Luxembourg in 2009 to that in 2011?
Your answer should be compact. 1.49. What is the ratio of the Exports(as % of merchandise exports) of Suriname in 2009 to that in 2011?
Keep it short and to the point. 0.5. What is the ratio of the Exports(as % of merchandise exports) in Bhutan in 2010 to that in 2011?
Keep it short and to the point. 0.89. What is the ratio of the Exports(as % of merchandise exports) of Cote d'Ivoire in 2010 to that in 2011?
Your answer should be very brief. 0.94. What is the ratio of the Exports(as % of merchandise exports) of Luxembourg in 2010 to that in 2011?
Provide a succinct answer. 1.13. What is the ratio of the Exports(as % of merchandise exports) of Suriname in 2010 to that in 2011?
Provide a short and direct response. 1.45. What is the difference between the highest and the second highest Exports(as % of merchandise exports) in Bhutan?
Your answer should be very brief. 6.45. What is the difference between the highest and the second highest Exports(as % of merchandise exports) in Cote d'Ivoire?
Ensure brevity in your answer.  0.39. What is the difference between the highest and the second highest Exports(as % of merchandise exports) in Luxembourg?
Make the answer very short. 0.3. What is the difference between the highest and the second highest Exports(as % of merchandise exports) in Suriname?
Offer a very short reply. 2.02. What is the difference between the highest and the lowest Exports(as % of merchandise exports) in Bhutan?
Your answer should be very brief. 47.74. What is the difference between the highest and the lowest Exports(as % of merchandise exports) in Cote d'Ivoire?
Provide a short and direct response. 13.3. What is the difference between the highest and the lowest Exports(as % of merchandise exports) of Luxembourg?
Provide a succinct answer. 0.49. What is the difference between the highest and the lowest Exports(as % of merchandise exports) in Suriname?
Your answer should be very brief. 8.52. 